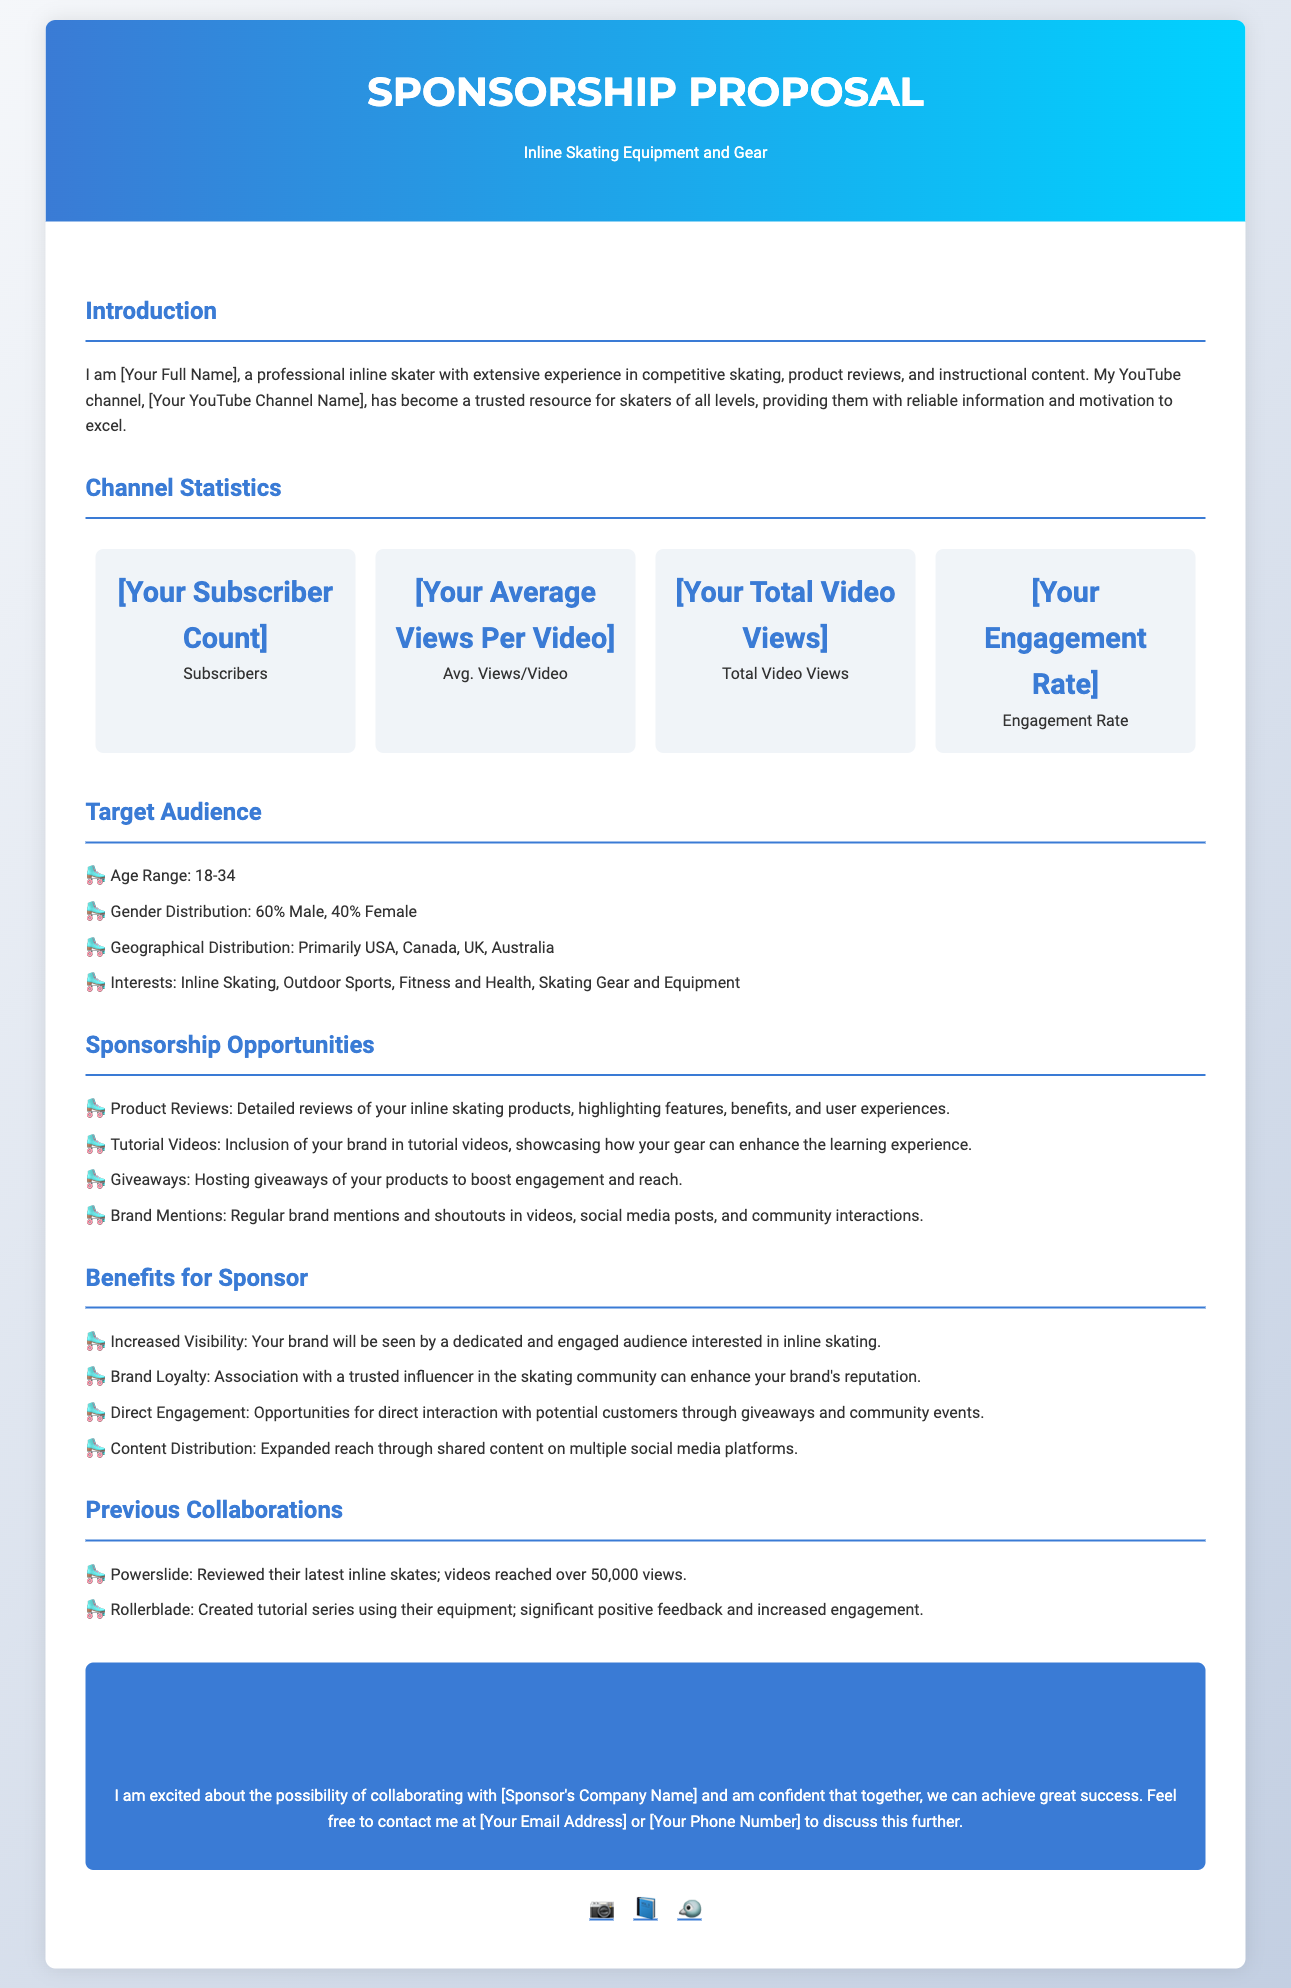What is the main focus of the proposal? The proposal focuses on seeking sponsorship for inline skating equipment and gear.
Answer: Inline Skating Equipment and Gear What is the subscriber count? The specific number is not provided, but it is a key statistic in the proposal.
Answer: [Your Subscriber Count] What is the engagement rate? This statistic indicates how actively the audience interacts with the content.
Answer: [Your Engagement Rate] What age range constitutes the target audience? The proposal identifies a specific demographic for potential sponsors.
Answer: 18-34 Name one sponsorship opportunity mentioned in the document. The document lists several ways the sponsor can collaborate.
Answer: Product Reviews What benefit does the sponsor gain from increased visibility? This aspect highlights the value of brand exposure through the channel.
Answer: Your brand will be seen by a dedicated and engaged audience interested in inline skating Which company was mentioned as a previous collaboration? This provides insight into past successful partnerships that may influence new sponsors.
Answer: Powerslide What type of content will feature the sponsor's gear? This specifies how the sponsorship can be integrated into existing content themes.
Answer: Tutorial Videos What is the primary platform for sharing content? Understanding the main distribution channel helps assess the proposal's reach.
Answer: YouTube What is the call-to-action in the document? It encourages potential sponsors to engage in further discussions about collaboration.
Answer: Let's Collaborate 